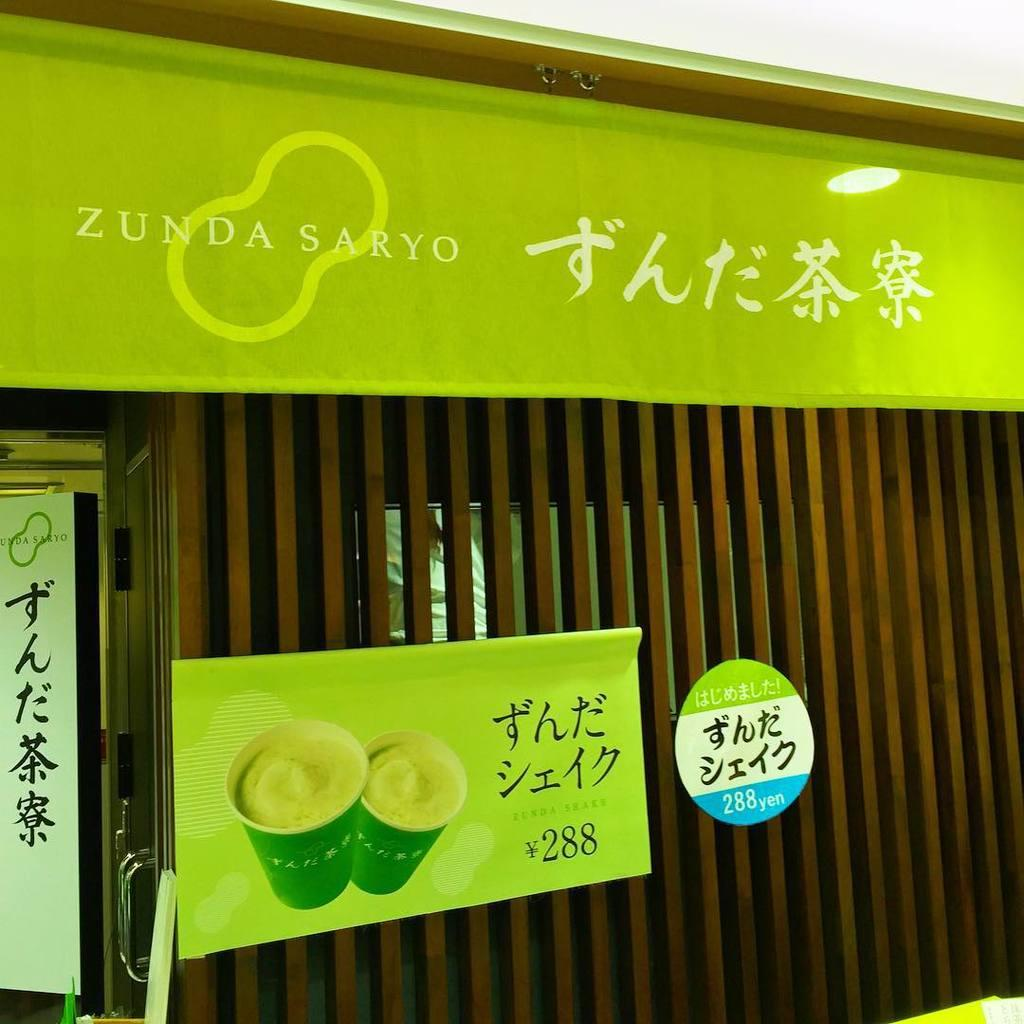What type of grill is shown in the image? There is a wooden grill in the image. Are there any decorations or markings on the wooden grill? Yes, there are hoardings or stickers on the wooden grill. What else can be seen in the image besides the wooden grill? There is a banner in the image. What is depicted on the banner? The banner has cups visible on it. What time is shown on the banner in the image? There is no time displayed on the banner in the image. What type of juice is being advertised on the banner? There is no juice being advertised on the banner in the image; it only shows cups. 